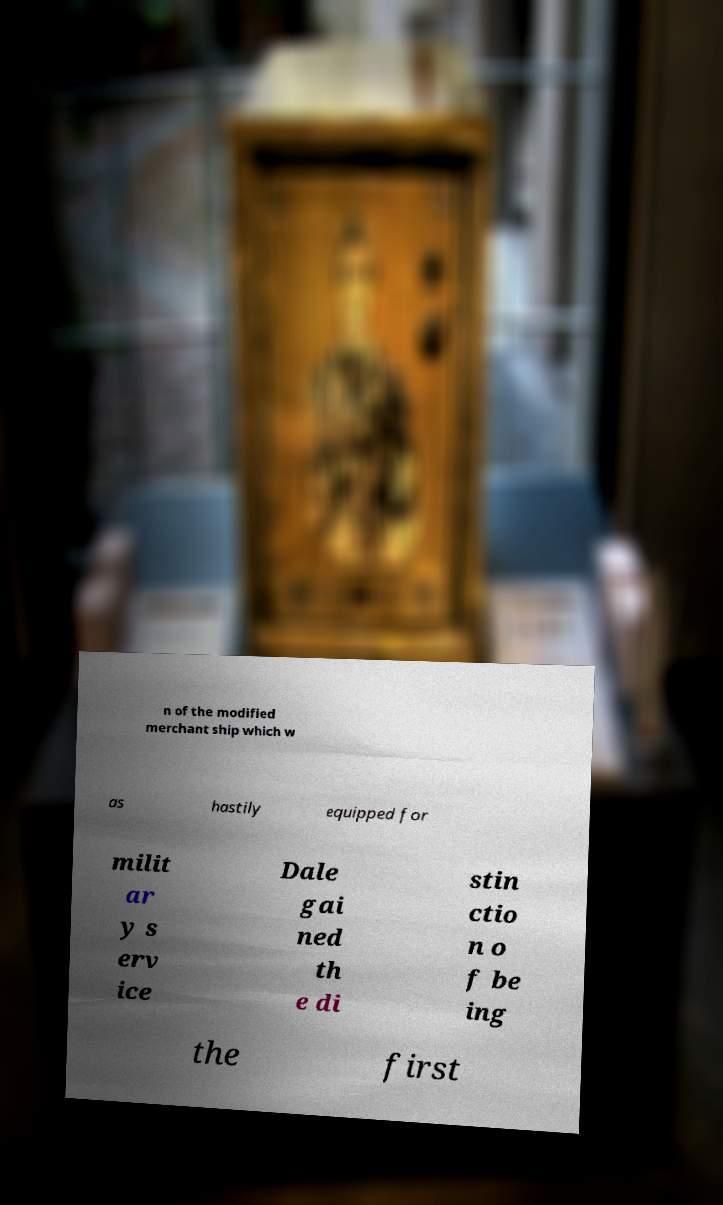Please identify and transcribe the text found in this image. n of the modified merchant ship which w as hastily equipped for milit ar y s erv ice Dale gai ned th e di stin ctio n o f be ing the first 